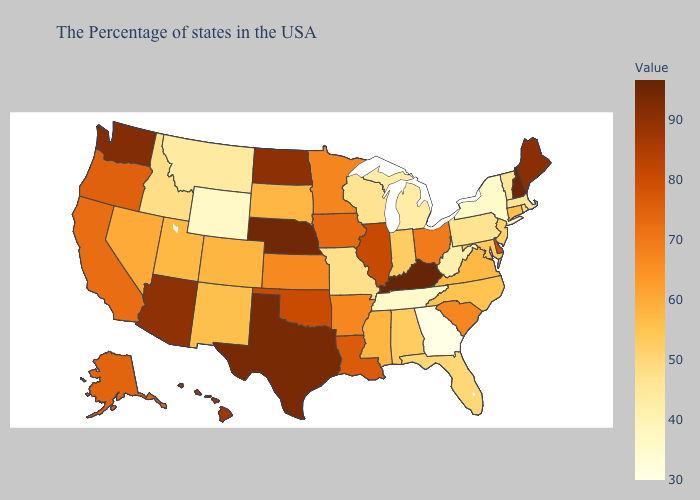Does the map have missing data?
Write a very short answer. No. Does Indiana have the lowest value in the MidWest?
Concise answer only. No. Does Arizona have the lowest value in the USA?
Short answer required. No. Which states have the lowest value in the South?
Write a very short answer. Georgia. Does Pennsylvania have a lower value than Tennessee?
Concise answer only. No. Does West Virginia have the highest value in the South?
Quick response, please. No. 